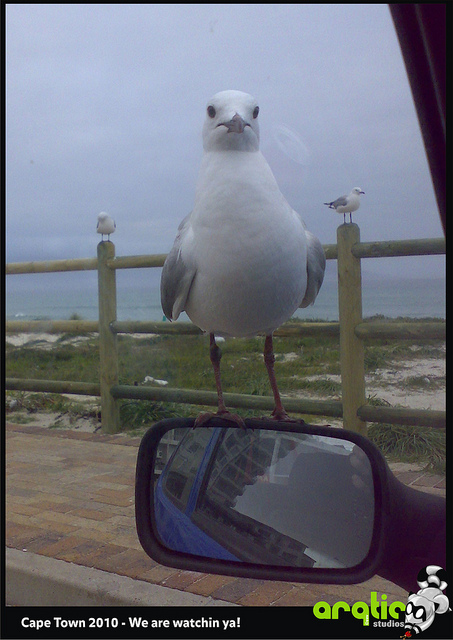Identify and read out the text in this image. cape Town 2010 We are Ya watchin arqtic studios 